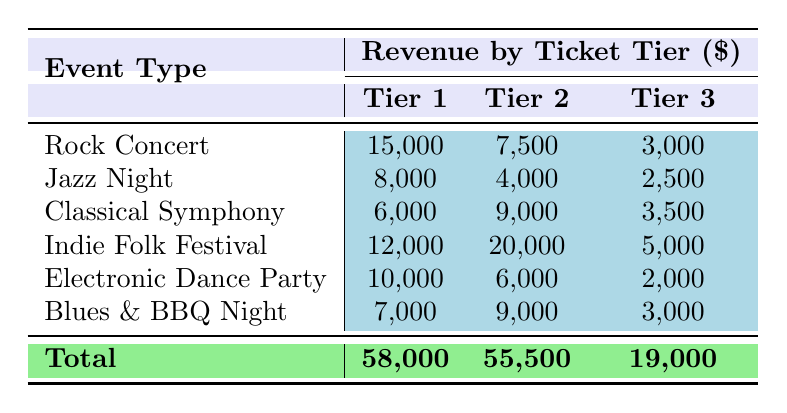What is the total revenue for the Rock Concert? The table shows that the revenue from the Rock Concert ticket tiers is 15,000 for General Admission, 7,500 for VIP, and 3,000 for Backstage Pass. Summing these values gives 15,000 + 7,500 + 3,000 = 25,500.
Answer: 25,500 Which event type generated the highest revenue from Tier 2 ticket sales? In the table, the Tier 2 revenues are 7,500 for Rock Concert, 4,000 for Jazz Night, 9,000 for Classical Symphony, 20,000 for Indie Folk Festival, 6,000 for Electronic Dance Party, and 9,000 for Blues & BBQ Night. The highest is 20,000 from Indie Folk Festival.
Answer: Indie Folk Festival What is the average revenue from Tier 3 ticket sales across all events? To find the average, we sum the Tier 3 revenues: 3,000 (Rock Concert) + 2,500 (Jazz Night) + 3,500 (Classical Symphony) + 5,000 (Indie Folk Festival) + 2,000 (Electronic Dance Party) + 3,000 (Blues & BBQ Night) = 19,000. Dividing this by the number of events (6) gives 19,000 / 6 ≈ 3,167.
Answer: 3,167 Is the total revenue greater for tickets from Tier 1 or Tier 2? The total revenue for Tier 1 is 58,000 and for Tier 2 is 55,500 as per the table. Since 58,000 is greater than 55,500, the total revenue for Tier 1 is greater.
Answer: Yes What is the total revenue for all event types combined? The table shows total revenues for each tier. Total revenue can be calculated by adding the totals: 58,000 (Tier 1) + 55,500 (Tier 2) + 19,000 (Tier 3) = 132,500.
Answer: 132,500 Which event type has the lowest total revenue, and how much is it? To find the event with the lowest total revenue, we need to calculate the total for each event: Rock Concert = 25,500, Jazz Night = 14,500, Classical Symphony = 18,500, Indie Folk Festival = 37,000, Electronic Dance Party = 18,000, and Blues & BBQ Night = 19,000. The lowest is Jazz Night at 14,500.
Answer: Jazz Night, 14,500 What revenue tier contributes the least total amount across all events? The totals for each tier are 58,000 for Tier 1, 55,500 for Tier 2, and 19,000 for Tier 3. The tier with the least contribution is Tier 3 at 19,000.
Answer: Tier 3 Which event type contributed the most to the overall revenue in Tier 1 sales? Referring to the table, the Tier 1 revenues are 15,000 (Rock Concert), 8,000 (Jazz Night), 6,000 (Classical Symphony), 12,000 (Indie Folk Festival), 10,000 (Electronic Dance Party), and 7,000 (Blues & BBQ Night). The highest is 15,000 from Rock Concert.
Answer: Rock Concert 